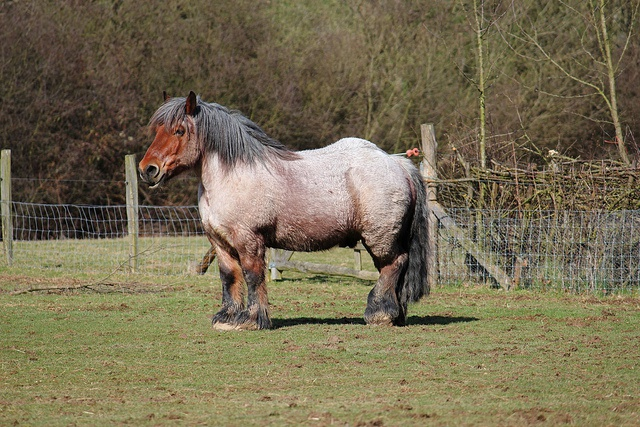Describe the objects in this image and their specific colors. I can see a horse in brown, lightgray, gray, black, and darkgray tones in this image. 